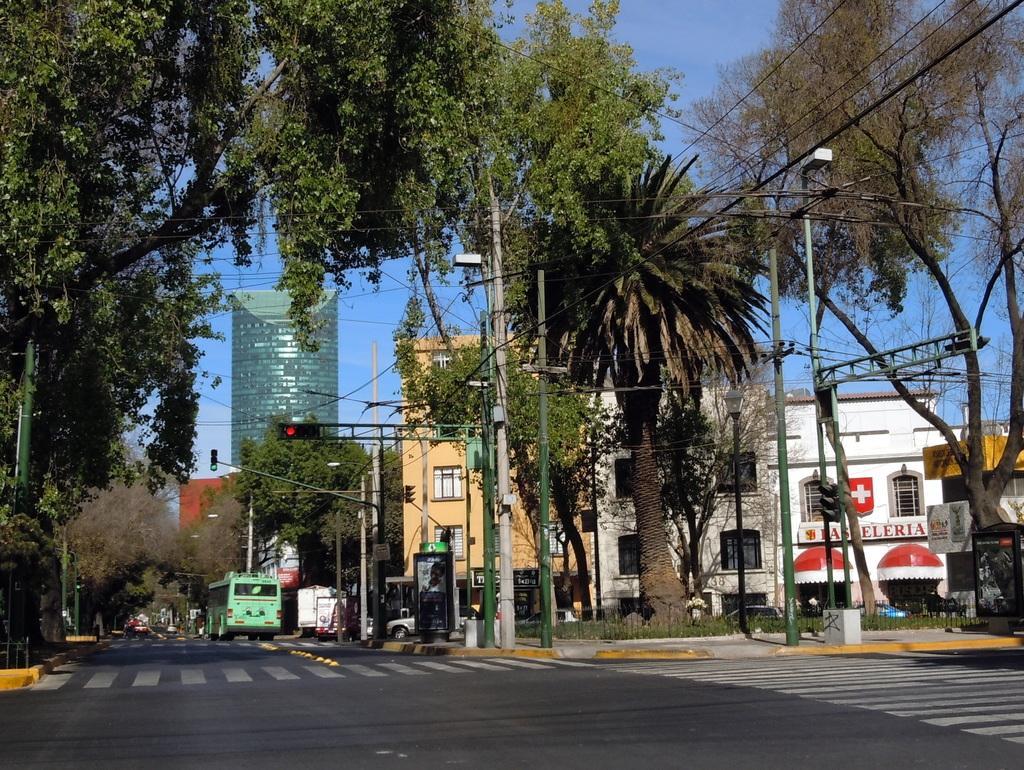Could you give a brief overview of what you see in this image? In this image I can see roads and on these roads I can see white lines and few vehicles. I can also see number of trees, number of poles, street lights, wires, signal lights, buildings and the sky. 